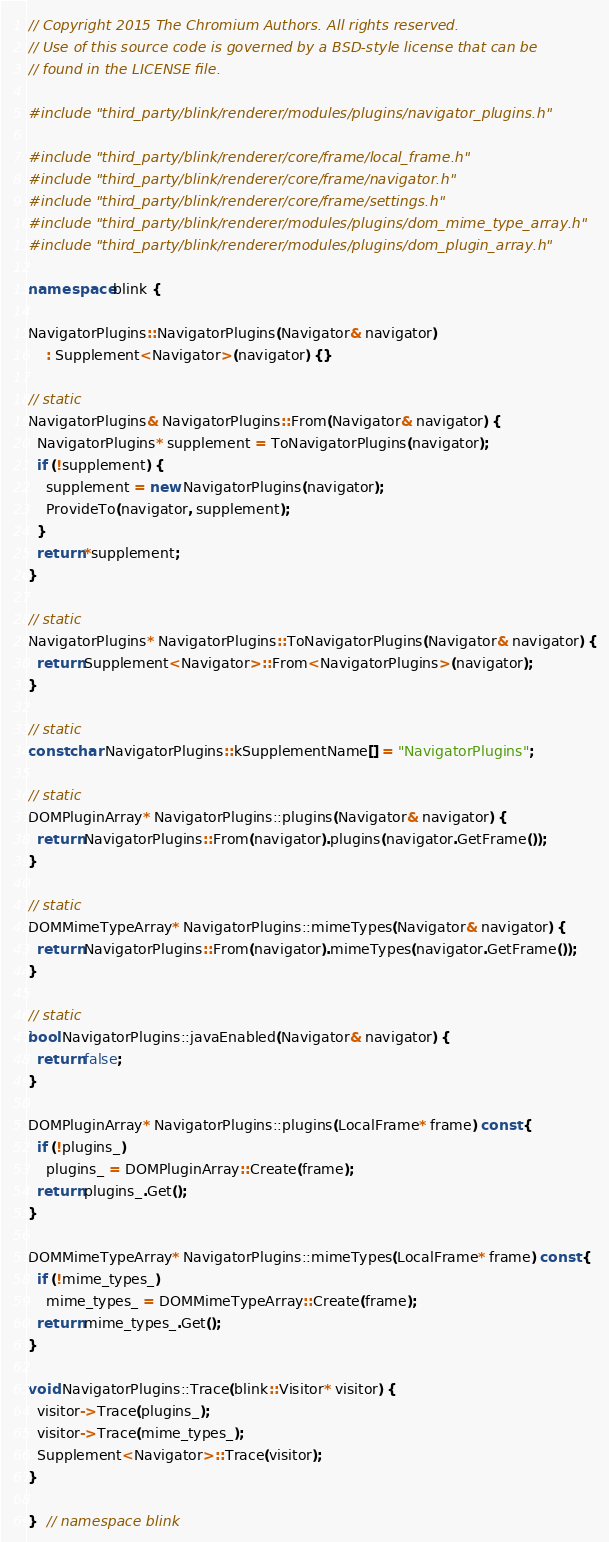Convert code to text. <code><loc_0><loc_0><loc_500><loc_500><_C++_>// Copyright 2015 The Chromium Authors. All rights reserved.
// Use of this source code is governed by a BSD-style license that can be
// found in the LICENSE file.

#include "third_party/blink/renderer/modules/plugins/navigator_plugins.h"

#include "third_party/blink/renderer/core/frame/local_frame.h"
#include "third_party/blink/renderer/core/frame/navigator.h"
#include "third_party/blink/renderer/core/frame/settings.h"
#include "third_party/blink/renderer/modules/plugins/dom_mime_type_array.h"
#include "third_party/blink/renderer/modules/plugins/dom_plugin_array.h"

namespace blink {

NavigatorPlugins::NavigatorPlugins(Navigator& navigator)
    : Supplement<Navigator>(navigator) {}

// static
NavigatorPlugins& NavigatorPlugins::From(Navigator& navigator) {
  NavigatorPlugins* supplement = ToNavigatorPlugins(navigator);
  if (!supplement) {
    supplement = new NavigatorPlugins(navigator);
    ProvideTo(navigator, supplement);
  }
  return *supplement;
}

// static
NavigatorPlugins* NavigatorPlugins::ToNavigatorPlugins(Navigator& navigator) {
  return Supplement<Navigator>::From<NavigatorPlugins>(navigator);
}

// static
const char NavigatorPlugins::kSupplementName[] = "NavigatorPlugins";

// static
DOMPluginArray* NavigatorPlugins::plugins(Navigator& navigator) {
  return NavigatorPlugins::From(navigator).plugins(navigator.GetFrame());
}

// static
DOMMimeTypeArray* NavigatorPlugins::mimeTypes(Navigator& navigator) {
  return NavigatorPlugins::From(navigator).mimeTypes(navigator.GetFrame());
}

// static
bool NavigatorPlugins::javaEnabled(Navigator& navigator) {
  return false;
}

DOMPluginArray* NavigatorPlugins::plugins(LocalFrame* frame) const {
  if (!plugins_)
    plugins_ = DOMPluginArray::Create(frame);
  return plugins_.Get();
}

DOMMimeTypeArray* NavigatorPlugins::mimeTypes(LocalFrame* frame) const {
  if (!mime_types_)
    mime_types_ = DOMMimeTypeArray::Create(frame);
  return mime_types_.Get();
}

void NavigatorPlugins::Trace(blink::Visitor* visitor) {
  visitor->Trace(plugins_);
  visitor->Trace(mime_types_);
  Supplement<Navigator>::Trace(visitor);
}

}  // namespace blink
</code> 